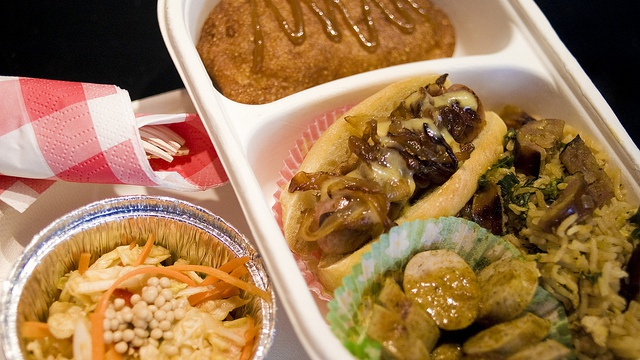Describe the objects in this image and their specific colors. I can see bowl in black, olive, white, and tan tones, sandwich in black, olive, tan, and maroon tones, hot dog in black, olive, tan, and maroon tones, bowl in black, white, tan, darkgray, and gray tones, and carrot in black, orange, and red tones in this image. 